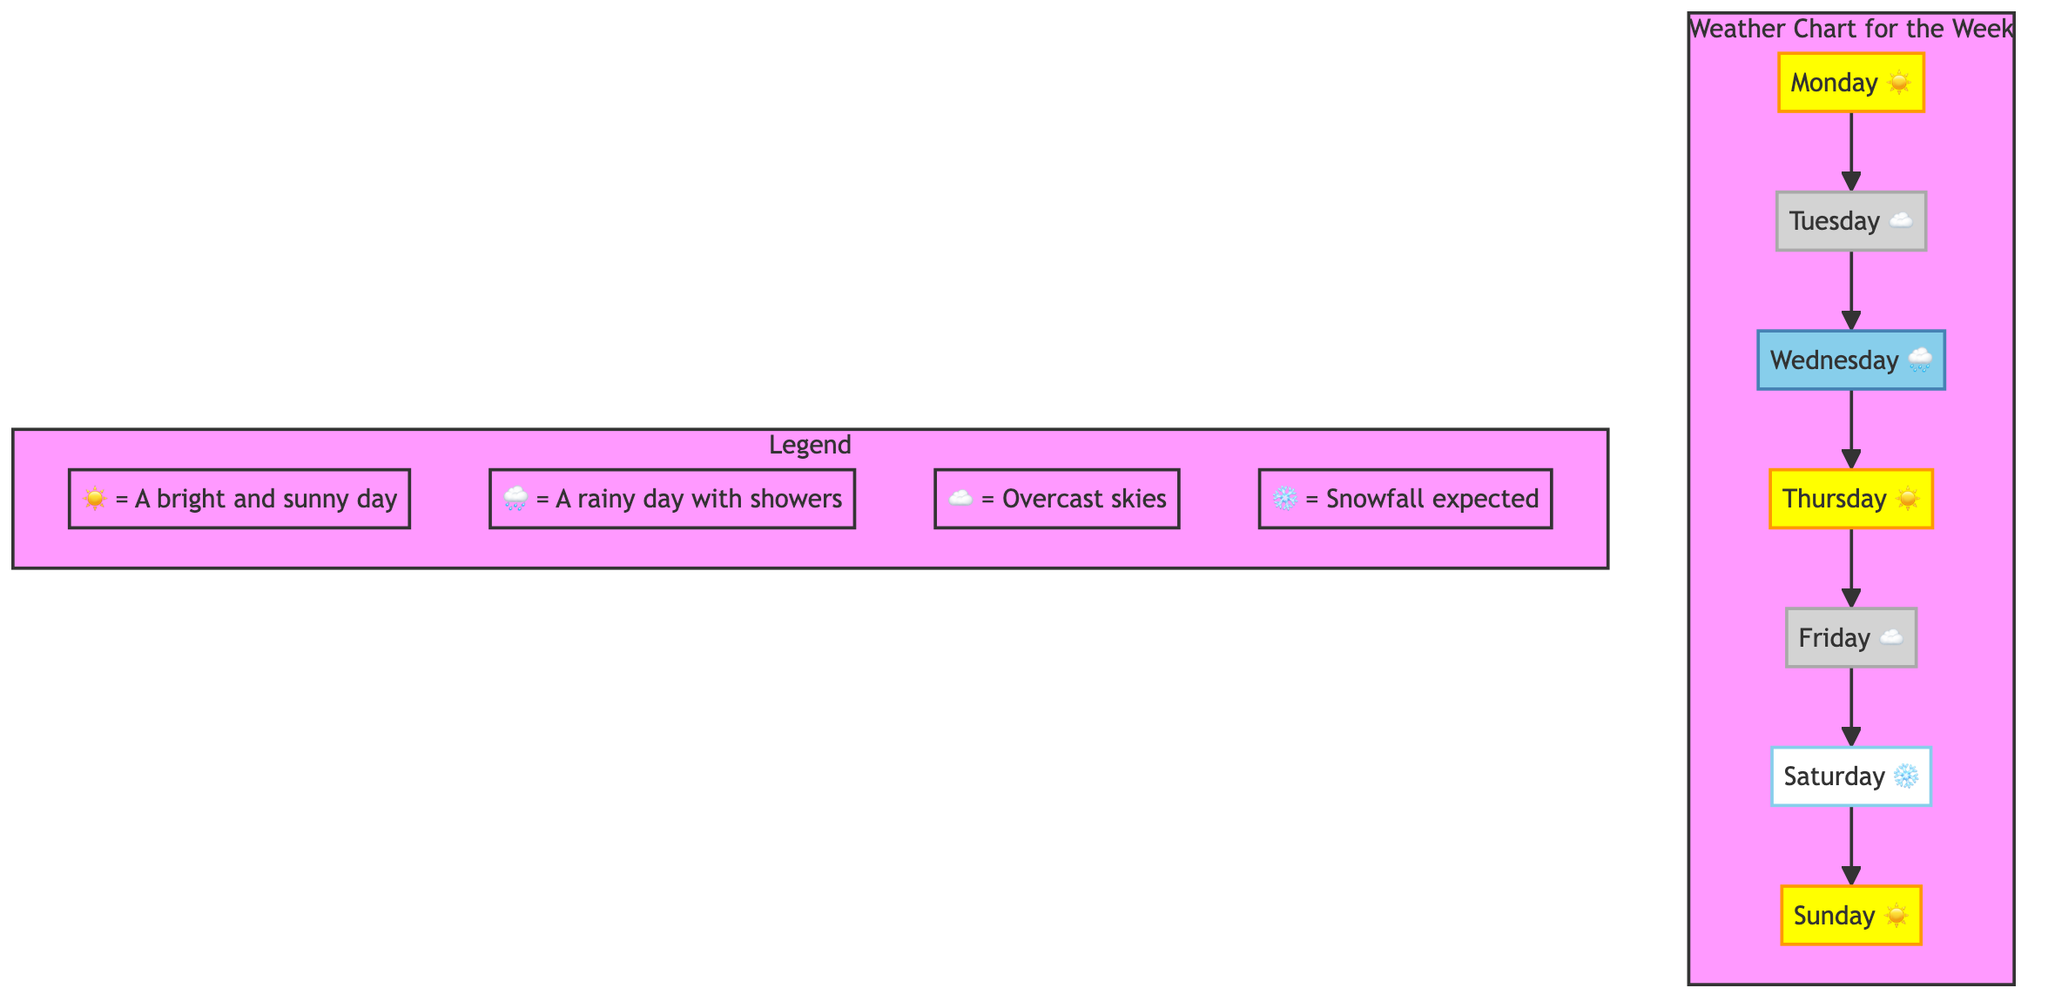What is the weather on Monday? The diagram shows a sunny symbol ☀️ below Monday, indicating that Monday's weather is sunny.
Answer: Sunny How many days are cloudy? The diagram includes two cloudy symbols ☁️, one for Tuesday and one for Friday, totaling two cloudy days.
Answer: Two Which day has a rainy forecast? The diagram depicts a rainy symbol 🌧️ under Wednesday, signifying that Wednesday's weather is rainy.
Answer: Wednesday What type of weather is expected on Saturday? The diagram presents a snowy symbol ❄️ for Saturday, indicating snowfall is expected on that day.
Answer: Snowy Which days have sunny weather? Looking at the diagram, Monday, Thursday, and Sunday each have a sunny symbol ☀️, meaning they are sunny days.
Answer: Monday, Thursday, Sunday How many unique weather conditions are shown in the diagram? The diagram displays four unique weather symbols: sunny, rainy, cloudy, and snowy, representing four different conditions.
Answer: Four What is the weather like on Thursday? Thursday in the diagram shows a sunny symbol ☀️, indicating that the weather is sunny on this day.
Answer: Sunny What does the snowy symbol ❄️ represent? In the legend of the diagram, the snowy symbol ❄️ is explicitly defined as indicating expected snowfall.
Answer: Snowfall expected Which day has both sunny and cloudy weather? The diagram shows that every day is represented individually without combinations; hence there are no days with both sunny and cloudy weather.
Answer: None 